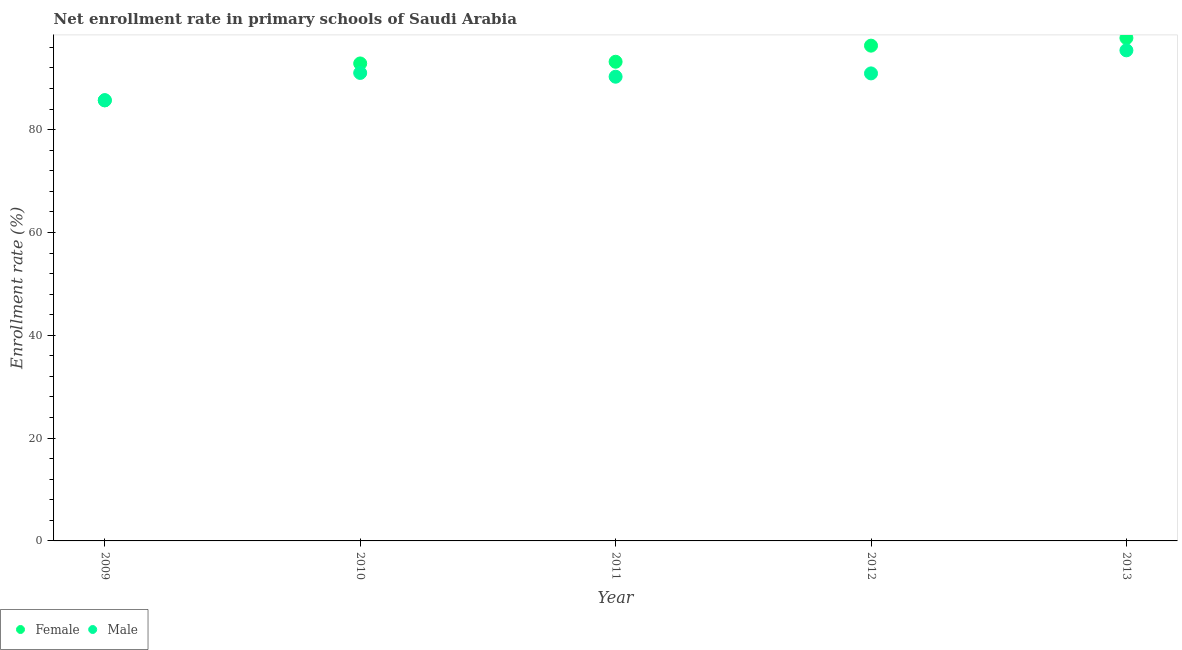Is the number of dotlines equal to the number of legend labels?
Make the answer very short. Yes. What is the enrollment rate of male students in 2013?
Your answer should be compact. 95.44. Across all years, what is the maximum enrollment rate of female students?
Give a very brief answer. 97.84. Across all years, what is the minimum enrollment rate of male students?
Offer a terse response. 85.73. What is the total enrollment rate of female students in the graph?
Your response must be concise. 465.98. What is the difference between the enrollment rate of female students in 2009 and that in 2013?
Offer a very short reply. -12.13. What is the difference between the enrollment rate of male students in 2011 and the enrollment rate of female students in 2012?
Make the answer very short. -6.04. What is the average enrollment rate of male students per year?
Ensure brevity in your answer.  90.69. In the year 2009, what is the difference between the enrollment rate of female students and enrollment rate of male students?
Your answer should be very brief. -0.03. What is the ratio of the enrollment rate of female students in 2010 to that in 2013?
Make the answer very short. 0.95. Is the difference between the enrollment rate of male students in 2009 and 2012 greater than the difference between the enrollment rate of female students in 2009 and 2012?
Provide a succinct answer. Yes. What is the difference between the highest and the second highest enrollment rate of female students?
Give a very brief answer. 1.49. What is the difference between the highest and the lowest enrollment rate of male students?
Keep it short and to the point. 9.7. In how many years, is the enrollment rate of female students greater than the average enrollment rate of female students taken over all years?
Provide a succinct answer. 3. Is the sum of the enrollment rate of female students in 2011 and 2013 greater than the maximum enrollment rate of male students across all years?
Give a very brief answer. Yes. Is the enrollment rate of female students strictly greater than the enrollment rate of male students over the years?
Provide a succinct answer. No. What is the difference between two consecutive major ticks on the Y-axis?
Offer a terse response. 20. Does the graph contain grids?
Provide a short and direct response. No. Where does the legend appear in the graph?
Make the answer very short. Bottom left. How are the legend labels stacked?
Ensure brevity in your answer.  Horizontal. What is the title of the graph?
Give a very brief answer. Net enrollment rate in primary schools of Saudi Arabia. Does "RDB concessional" appear as one of the legend labels in the graph?
Ensure brevity in your answer.  No. What is the label or title of the X-axis?
Give a very brief answer. Year. What is the label or title of the Y-axis?
Give a very brief answer. Enrollment rate (%). What is the Enrollment rate (%) of Female in 2009?
Your answer should be very brief. 85.7. What is the Enrollment rate (%) of Male in 2009?
Offer a very short reply. 85.73. What is the Enrollment rate (%) of Female in 2010?
Make the answer very short. 92.88. What is the Enrollment rate (%) of Male in 2010?
Make the answer very short. 91.04. What is the Enrollment rate (%) in Female in 2011?
Provide a succinct answer. 93.21. What is the Enrollment rate (%) of Male in 2011?
Your answer should be compact. 90.3. What is the Enrollment rate (%) of Female in 2012?
Provide a succinct answer. 96.35. What is the Enrollment rate (%) of Male in 2012?
Provide a short and direct response. 90.95. What is the Enrollment rate (%) of Female in 2013?
Provide a short and direct response. 97.84. What is the Enrollment rate (%) in Male in 2013?
Ensure brevity in your answer.  95.44. Across all years, what is the maximum Enrollment rate (%) of Female?
Provide a succinct answer. 97.84. Across all years, what is the maximum Enrollment rate (%) in Male?
Make the answer very short. 95.44. Across all years, what is the minimum Enrollment rate (%) in Female?
Your answer should be very brief. 85.7. Across all years, what is the minimum Enrollment rate (%) of Male?
Offer a terse response. 85.73. What is the total Enrollment rate (%) of Female in the graph?
Ensure brevity in your answer.  465.98. What is the total Enrollment rate (%) of Male in the graph?
Your response must be concise. 453.46. What is the difference between the Enrollment rate (%) in Female in 2009 and that in 2010?
Give a very brief answer. -7.18. What is the difference between the Enrollment rate (%) in Male in 2009 and that in 2010?
Give a very brief answer. -5.3. What is the difference between the Enrollment rate (%) of Female in 2009 and that in 2011?
Your answer should be very brief. -7.51. What is the difference between the Enrollment rate (%) in Male in 2009 and that in 2011?
Make the answer very short. -4.57. What is the difference between the Enrollment rate (%) in Female in 2009 and that in 2012?
Offer a very short reply. -10.64. What is the difference between the Enrollment rate (%) in Male in 2009 and that in 2012?
Make the answer very short. -5.21. What is the difference between the Enrollment rate (%) in Female in 2009 and that in 2013?
Give a very brief answer. -12.13. What is the difference between the Enrollment rate (%) of Male in 2009 and that in 2013?
Give a very brief answer. -9.7. What is the difference between the Enrollment rate (%) in Female in 2010 and that in 2011?
Offer a terse response. -0.33. What is the difference between the Enrollment rate (%) in Male in 2010 and that in 2011?
Give a very brief answer. 0.73. What is the difference between the Enrollment rate (%) in Female in 2010 and that in 2012?
Ensure brevity in your answer.  -3.46. What is the difference between the Enrollment rate (%) of Male in 2010 and that in 2012?
Keep it short and to the point. 0.09. What is the difference between the Enrollment rate (%) in Female in 2010 and that in 2013?
Keep it short and to the point. -4.95. What is the difference between the Enrollment rate (%) of Male in 2010 and that in 2013?
Keep it short and to the point. -4.4. What is the difference between the Enrollment rate (%) of Female in 2011 and that in 2012?
Provide a short and direct response. -3.13. What is the difference between the Enrollment rate (%) in Male in 2011 and that in 2012?
Offer a terse response. -0.64. What is the difference between the Enrollment rate (%) in Female in 2011 and that in 2013?
Offer a terse response. -4.62. What is the difference between the Enrollment rate (%) of Male in 2011 and that in 2013?
Give a very brief answer. -5.13. What is the difference between the Enrollment rate (%) of Female in 2012 and that in 2013?
Give a very brief answer. -1.49. What is the difference between the Enrollment rate (%) in Male in 2012 and that in 2013?
Provide a succinct answer. -4.49. What is the difference between the Enrollment rate (%) of Female in 2009 and the Enrollment rate (%) of Male in 2010?
Keep it short and to the point. -5.34. What is the difference between the Enrollment rate (%) of Female in 2009 and the Enrollment rate (%) of Male in 2011?
Make the answer very short. -4.6. What is the difference between the Enrollment rate (%) of Female in 2009 and the Enrollment rate (%) of Male in 2012?
Offer a very short reply. -5.25. What is the difference between the Enrollment rate (%) in Female in 2009 and the Enrollment rate (%) in Male in 2013?
Your response must be concise. -9.73. What is the difference between the Enrollment rate (%) in Female in 2010 and the Enrollment rate (%) in Male in 2011?
Keep it short and to the point. 2.58. What is the difference between the Enrollment rate (%) of Female in 2010 and the Enrollment rate (%) of Male in 2012?
Give a very brief answer. 1.94. What is the difference between the Enrollment rate (%) of Female in 2010 and the Enrollment rate (%) of Male in 2013?
Your answer should be compact. -2.55. What is the difference between the Enrollment rate (%) of Female in 2011 and the Enrollment rate (%) of Male in 2012?
Your response must be concise. 2.27. What is the difference between the Enrollment rate (%) in Female in 2011 and the Enrollment rate (%) in Male in 2013?
Your answer should be very brief. -2.22. What is the difference between the Enrollment rate (%) in Female in 2012 and the Enrollment rate (%) in Male in 2013?
Make the answer very short. 0.91. What is the average Enrollment rate (%) of Female per year?
Your answer should be very brief. 93.2. What is the average Enrollment rate (%) in Male per year?
Keep it short and to the point. 90.69. In the year 2009, what is the difference between the Enrollment rate (%) of Female and Enrollment rate (%) of Male?
Provide a short and direct response. -0.03. In the year 2010, what is the difference between the Enrollment rate (%) of Female and Enrollment rate (%) of Male?
Your answer should be very brief. 1.84. In the year 2011, what is the difference between the Enrollment rate (%) of Female and Enrollment rate (%) of Male?
Keep it short and to the point. 2.91. In the year 2012, what is the difference between the Enrollment rate (%) in Female and Enrollment rate (%) in Male?
Your answer should be very brief. 5.4. In the year 2013, what is the difference between the Enrollment rate (%) of Female and Enrollment rate (%) of Male?
Provide a succinct answer. 2.4. What is the ratio of the Enrollment rate (%) of Female in 2009 to that in 2010?
Your answer should be compact. 0.92. What is the ratio of the Enrollment rate (%) in Male in 2009 to that in 2010?
Your response must be concise. 0.94. What is the ratio of the Enrollment rate (%) of Female in 2009 to that in 2011?
Provide a succinct answer. 0.92. What is the ratio of the Enrollment rate (%) in Male in 2009 to that in 2011?
Your answer should be compact. 0.95. What is the ratio of the Enrollment rate (%) of Female in 2009 to that in 2012?
Offer a terse response. 0.89. What is the ratio of the Enrollment rate (%) in Male in 2009 to that in 2012?
Offer a terse response. 0.94. What is the ratio of the Enrollment rate (%) in Female in 2009 to that in 2013?
Keep it short and to the point. 0.88. What is the ratio of the Enrollment rate (%) of Male in 2009 to that in 2013?
Make the answer very short. 0.9. What is the ratio of the Enrollment rate (%) in Female in 2010 to that in 2011?
Give a very brief answer. 1. What is the ratio of the Enrollment rate (%) of Male in 2010 to that in 2011?
Your answer should be very brief. 1.01. What is the ratio of the Enrollment rate (%) in Female in 2010 to that in 2012?
Your answer should be very brief. 0.96. What is the ratio of the Enrollment rate (%) in Male in 2010 to that in 2012?
Give a very brief answer. 1. What is the ratio of the Enrollment rate (%) of Female in 2010 to that in 2013?
Provide a short and direct response. 0.95. What is the ratio of the Enrollment rate (%) of Male in 2010 to that in 2013?
Your response must be concise. 0.95. What is the ratio of the Enrollment rate (%) in Female in 2011 to that in 2012?
Give a very brief answer. 0.97. What is the ratio of the Enrollment rate (%) of Male in 2011 to that in 2012?
Your answer should be very brief. 0.99. What is the ratio of the Enrollment rate (%) of Female in 2011 to that in 2013?
Offer a terse response. 0.95. What is the ratio of the Enrollment rate (%) in Male in 2011 to that in 2013?
Keep it short and to the point. 0.95. What is the ratio of the Enrollment rate (%) of Female in 2012 to that in 2013?
Your response must be concise. 0.98. What is the ratio of the Enrollment rate (%) in Male in 2012 to that in 2013?
Provide a short and direct response. 0.95. What is the difference between the highest and the second highest Enrollment rate (%) in Female?
Your answer should be very brief. 1.49. What is the difference between the highest and the second highest Enrollment rate (%) in Male?
Your answer should be very brief. 4.4. What is the difference between the highest and the lowest Enrollment rate (%) of Female?
Your response must be concise. 12.13. What is the difference between the highest and the lowest Enrollment rate (%) in Male?
Offer a very short reply. 9.7. 